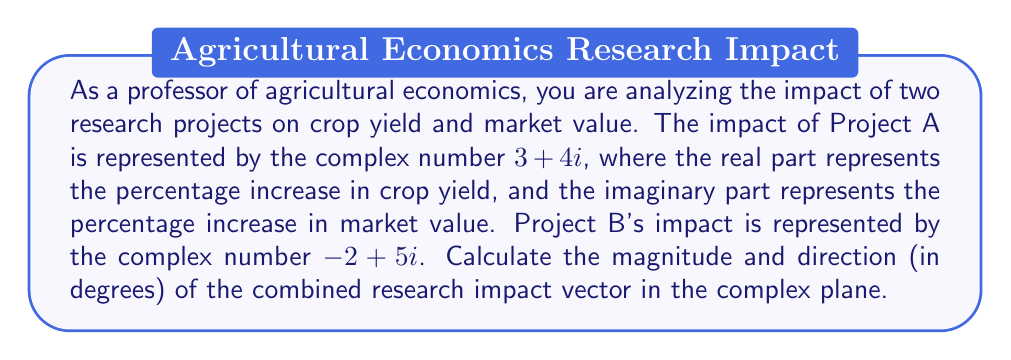Help me with this question. To solve this problem, we need to follow these steps:

1. Add the complex numbers representing the two projects to get the combined impact vector.
2. Calculate the magnitude of the combined vector using the absolute value formula.
3. Calculate the direction of the combined vector using the argument formula.

Step 1: Combined impact vector
$$(3 + 4i) + (-2 + 5i) = 1 + 9i$$

Step 2: Magnitude
The magnitude of a complex number $a + bi$ is given by $\sqrt{a^2 + b^2}$.
$$|1 + 9i| = \sqrt{1^2 + 9^2} = \sqrt{82}$$

Step 3: Direction
The direction (argument) of a complex number $a + bi$ is given by $\tan^{-1}(\frac{b}{a})$. However, we need to be careful about the quadrant.

$$\theta = \tan^{-1}(\frac{9}{1}) = \tan^{-1}(9)$$

Since both the real and imaginary parts are positive, the angle is in the first quadrant, so no adjustment is needed.

To convert this to degrees, we multiply by $\frac{180}{\pi}$.

$$\theta_{degrees} = \tan^{-1}(9) \cdot \frac{180}{\pi} \approx 83.66°$$

[asy]
import geometry;

size(200);
real[] ticksX = {-10,-8,-6,-4,-2,0,2,4,6,8,10};
real[] ticksY = {-10,-8,-6,-4,-2,0,2,4,6,8,10};

xaxis("Re", Ticks(ticksX));
yaxis("Im", Ticks(ticksY));

draw((0,0)--(1,9), arrow=Arrow(TeXHead));
label("1 + 9i", (1,9), NE);

dot((1,9));
[/asy]
Answer: The magnitude of the combined research impact vector is $\sqrt{82}$, and its direction is approximately $83.66°$. 